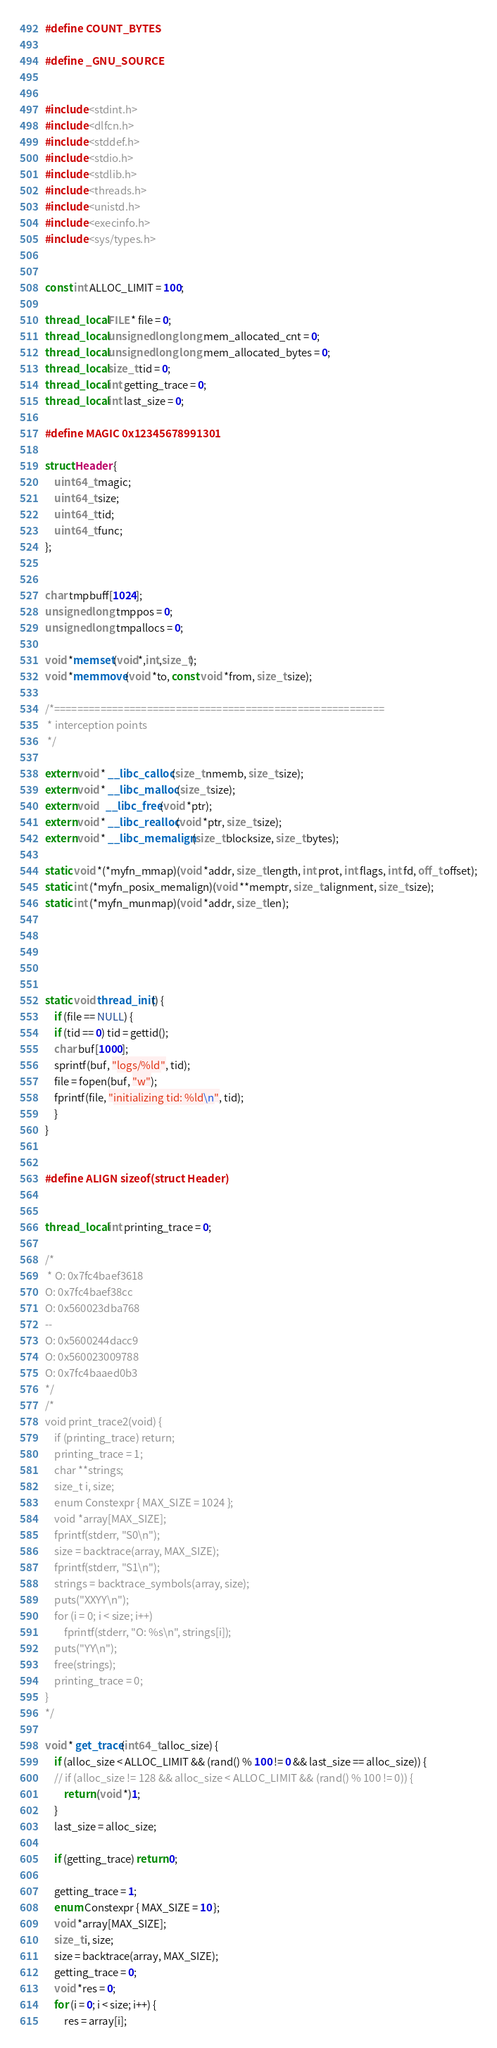Convert code to text. <code><loc_0><loc_0><loc_500><loc_500><_C_>#define COUNT_BYTES

#define _GNU_SOURCE


#include <stdint.h>
#include <dlfcn.h>
#include <stddef.h>
#include <stdio.h>
#include <stdlib.h>
#include <threads.h>
#include <unistd.h>
#include <execinfo.h>
#include <sys/types.h>


const int ALLOC_LIMIT = 100;

thread_local FILE * file = 0;
thread_local unsigned long long mem_allocated_cnt = 0;
thread_local unsigned long long mem_allocated_bytes = 0;
thread_local size_t tid = 0;
thread_local int getting_trace = 0;
thread_local int last_size = 0;

#define MAGIC 0x12345678991301

struct Header {
    uint64_t magic;
    uint64_t size;
    uint64_t tid;
    uint64_t func;
};


char tmpbuff[1024];
unsigned long tmppos = 0;
unsigned long tmpallocs = 0;

void *memset(void*,int,size_t);
void *memmove(void *to, const void *from, size_t size);

/*=========================================================
 * interception points
 */

extern void * __libc_calloc(size_t nmemb, size_t size);
extern void * __libc_malloc(size_t size);
extern void   __libc_free(void *ptr);
extern void * __libc_realloc(void *ptr, size_t size);
extern void * __libc_memalign(size_t blocksize, size_t bytes);

static void *(*myfn_mmap)(void *addr, size_t length, int prot, int flags, int fd, off_t offset);
static int (*myfn_posix_memalign)(void **memptr, size_t alignment, size_t size);
static int (*myfn_munmap)(void *addr, size_t len);





static void thread_init() {
    if (file == NULL) {
	if (tid == 0) tid = gettid();
	char buf[1000];
	sprintf(buf, "logs/%ld", tid);
	file = fopen(buf, "w");
	fprintf(file, "initializing tid: %ld\n", tid);
    }
}


#define ALIGN sizeof(struct Header)


thread_local int printing_trace = 0;

/*
 * O: 0x7fc4baef3618
O: 0x7fc4baef38cc
O: 0x560023dba768
--
O: 0x5600244dacc9
O: 0x560023009788
O: 0x7fc4baaed0b3
*/
/*
void print_trace2(void) {
    if (printing_trace) return;
    printing_trace = 1;
    char **strings;
    size_t i, size;
    enum Constexpr { MAX_SIZE = 1024 };
    void *array[MAX_SIZE];
    fprintf(stderr, "S0\n");
    size = backtrace(array, MAX_SIZE);
    fprintf(stderr, "S1\n");
    strings = backtrace_symbols(array, size);
    puts("XXYY\n");
    for (i = 0; i < size; i++)
        fprintf(stderr, "O: %s\n", strings[i]);
    puts("YY\n");
    free(strings);
    printing_trace = 0;
}
*/

void * get_trace(int64_t alloc_size) {
    if (alloc_size < ALLOC_LIMIT && (rand() % 100 != 0 && last_size == alloc_size)) {
    // if (alloc_size != 128 && alloc_size < ALLOC_LIMIT && (rand() % 100 != 0)) {
        return (void *)1;
    }
    last_size = alloc_size;

    if (getting_trace) return 0;

    getting_trace = 1;
    enum Constexpr { MAX_SIZE = 10 };
    void *array[MAX_SIZE];
    size_t i, size;
    size = backtrace(array, MAX_SIZE);
    getting_trace = 0;
    void *res = 0;
    for (i = 0; i < size; i++) {
	    res = array[i];</code> 